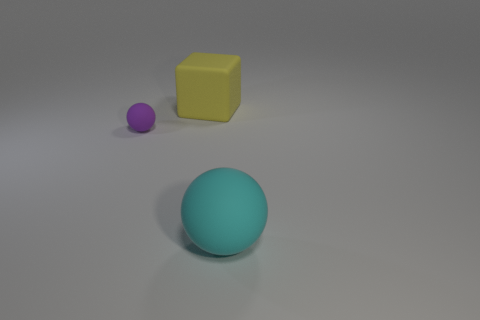Add 2 small brown things. How many objects exist? 5 Subtract all cyan balls. How many balls are left? 1 Subtract all brown cylinders. How many cyan blocks are left? 0 Add 3 cyan matte balls. How many cyan matte balls are left? 4 Add 1 tiny blue spheres. How many tiny blue spheres exist? 1 Subtract 0 green cubes. How many objects are left? 3 Subtract all spheres. How many objects are left? 1 Subtract 2 spheres. How many spheres are left? 0 Subtract all blue cubes. Subtract all yellow cylinders. How many cubes are left? 1 Subtract all cyan matte objects. Subtract all rubber spheres. How many objects are left? 0 